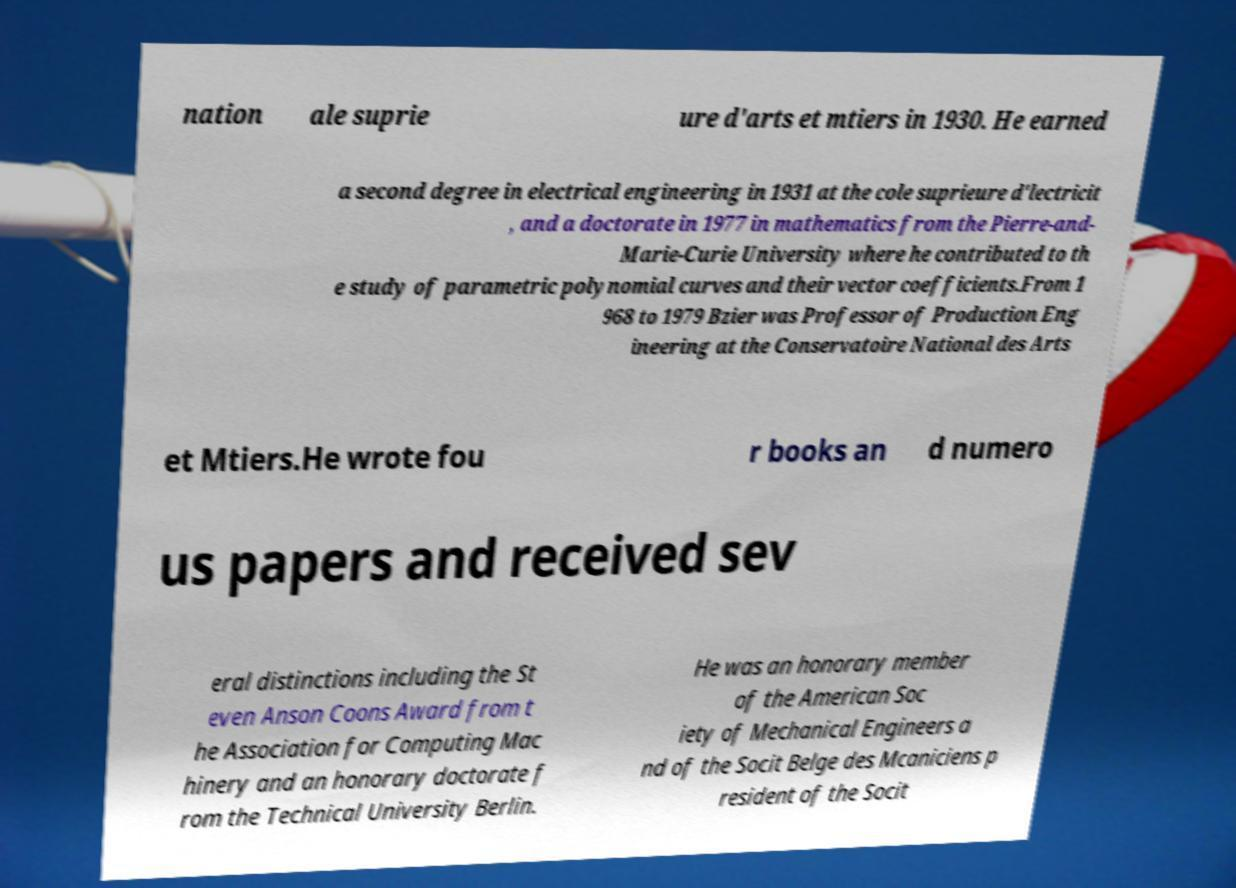Could you assist in decoding the text presented in this image and type it out clearly? nation ale suprie ure d'arts et mtiers in 1930. He earned a second degree in electrical engineering in 1931 at the cole suprieure d'lectricit , and a doctorate in 1977 in mathematics from the Pierre-and- Marie-Curie University where he contributed to th e study of parametric polynomial curves and their vector coefficients.From 1 968 to 1979 Bzier was Professor of Production Eng ineering at the Conservatoire National des Arts et Mtiers.He wrote fou r books an d numero us papers and received sev eral distinctions including the St even Anson Coons Award from t he Association for Computing Mac hinery and an honorary doctorate f rom the Technical University Berlin. He was an honorary member of the American Soc iety of Mechanical Engineers a nd of the Socit Belge des Mcaniciens p resident of the Socit 